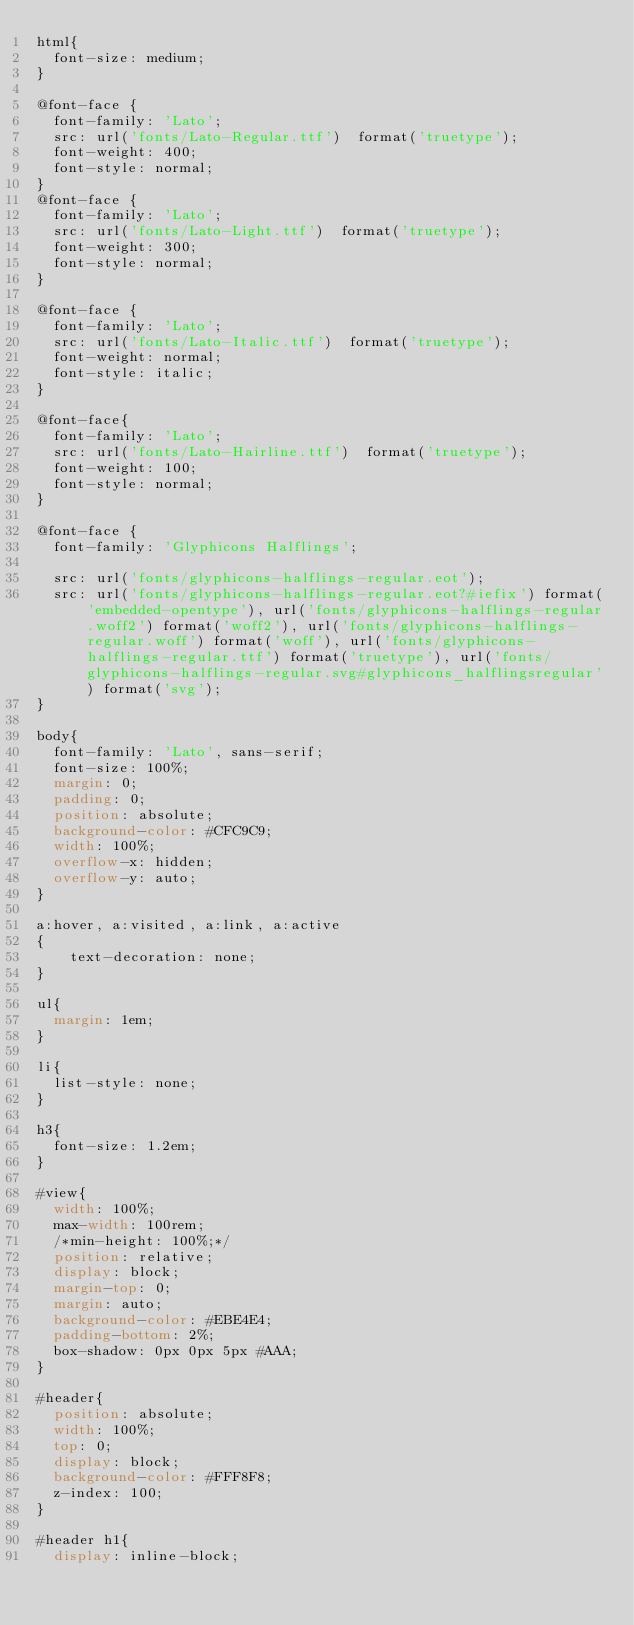<code> <loc_0><loc_0><loc_500><loc_500><_CSS_>html{
  font-size: medium;
}

@font-face {
  font-family: 'Lato';
  src: url('fonts/Lato-Regular.ttf')  format('truetype');
  font-weight: 400;
  font-style: normal;
}
@font-face {
  font-family: 'Lato';
  src: url('fonts/Lato-Light.ttf')  format('truetype');
  font-weight: 300;
  font-style: normal;
}

@font-face {
  font-family: 'Lato';
  src: url('fonts/Lato-Italic.ttf')  format('truetype');
  font-weight: normal;
  font-style: italic;
}

@font-face{
  font-family: 'Lato';
  src: url('fonts/Lato-Hairline.ttf')  format('truetype');
  font-weight: 100;
  font-style: normal;
}

@font-face {
  font-family: 'Glyphicons Halflings';

  src: url('fonts/glyphicons-halflings-regular.eot');
  src: url('fonts/glyphicons-halflings-regular.eot?#iefix') format('embedded-opentype'), url('fonts/glyphicons-halflings-regular.woff2') format('woff2'), url('fonts/glyphicons-halflings-regular.woff') format('woff'), url('fonts/glyphicons-halflings-regular.ttf') format('truetype'), url('fonts/glyphicons-halflings-regular.svg#glyphicons_halflingsregular') format('svg');
}

body{
  font-family: 'Lato', sans-serif;
  font-size: 100%;
  margin: 0;
  padding: 0;
  position: absolute;
  background-color: #CFC9C9;
  width: 100%;
  overflow-x: hidden;
  overflow-y: auto;
}

a:hover, a:visited, a:link, a:active
{
    text-decoration: none;
}

ul{
  margin: 1em;
}

li{
  list-style: none;
}

h3{
  font-size: 1.2em;
}

#view{
  width: 100%;
  max-width: 100rem;
  /*min-height: 100%;*/
  position: relative;
  display: block;
  margin-top: 0;
  margin: auto;
  background-color: #EBE4E4;
  padding-bottom: 2%;
  box-shadow: 0px 0px 5px #AAA;
}

#header{
  position: absolute;
  width: 100%;
  top: 0;
  display: block;
  background-color: #FFF8F8;
  z-index: 100;
}

#header h1{
  display: inline-block;</code> 